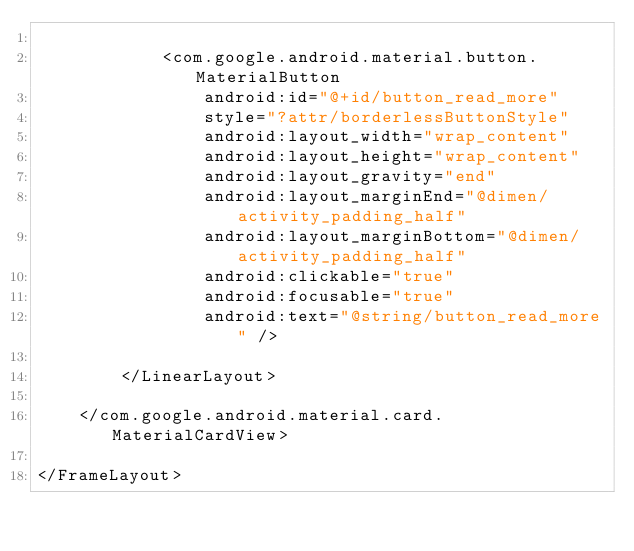<code> <loc_0><loc_0><loc_500><loc_500><_XML_>
            <com.google.android.material.button.MaterialButton
                android:id="@+id/button_read_more"
                style="?attr/borderlessButtonStyle"
                android:layout_width="wrap_content"
                android:layout_height="wrap_content"
                android:layout_gravity="end"
                android:layout_marginEnd="@dimen/activity_padding_half"
                android:layout_marginBottom="@dimen/activity_padding_half"
                android:clickable="true"
                android:focusable="true"
                android:text="@string/button_read_more" />

        </LinearLayout>

    </com.google.android.material.card.MaterialCardView>

</FrameLayout></code> 